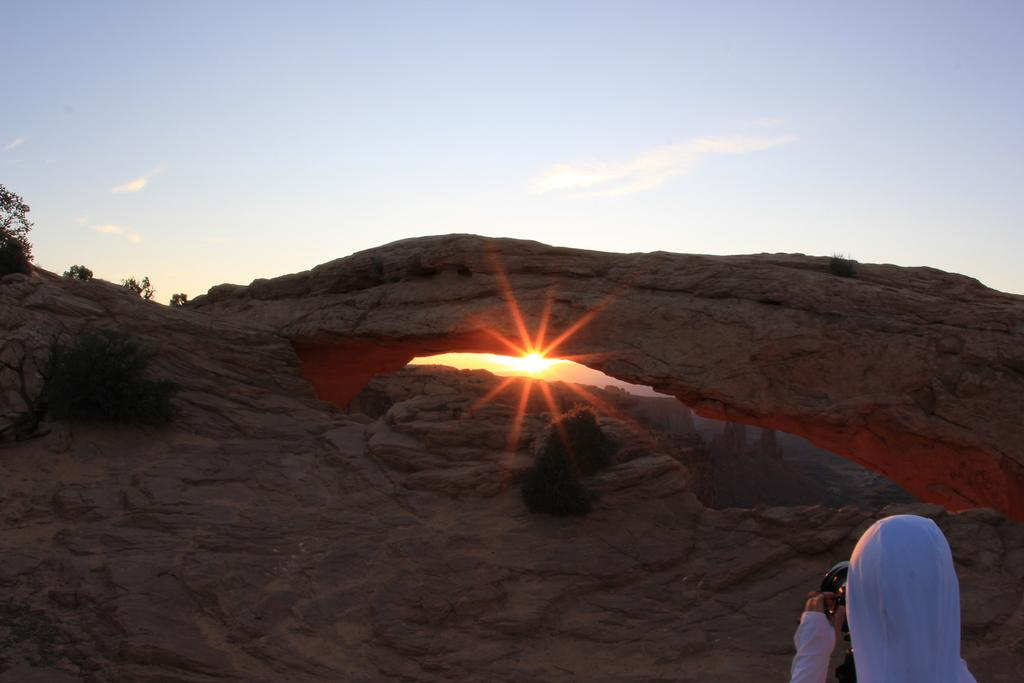What is the main subject of the image? There is a person standing in the image. What can be seen in the background of the image? There is a mountain and the sky visible in the background of the image. What is the condition of the sky in the image? The sun is present in the sky, indicating a clear day. How many deer can be seen grazing in the foreground of the image? There are no deer present in the image; it features a person standing in front of a mountain with a clear sky. 